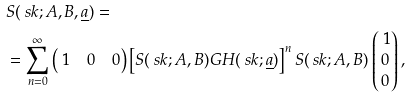Convert formula to latex. <formula><loc_0><loc_0><loc_500><loc_500>& S ( \ s k ; A , B , \underline { a } ) = \\ & = \sum _ { n = 0 } ^ { \infty } \begin{pmatrix} \ 1 & 0 & 0 \end{pmatrix} \left [ S ( \ s k ; A , B ) G H ( \ s k ; \underline { a } ) \right ] ^ { n } S ( \ s k ; A , B ) \begin{pmatrix} \ 1 \\ 0 \\ 0 \end{pmatrix} ,</formula> 